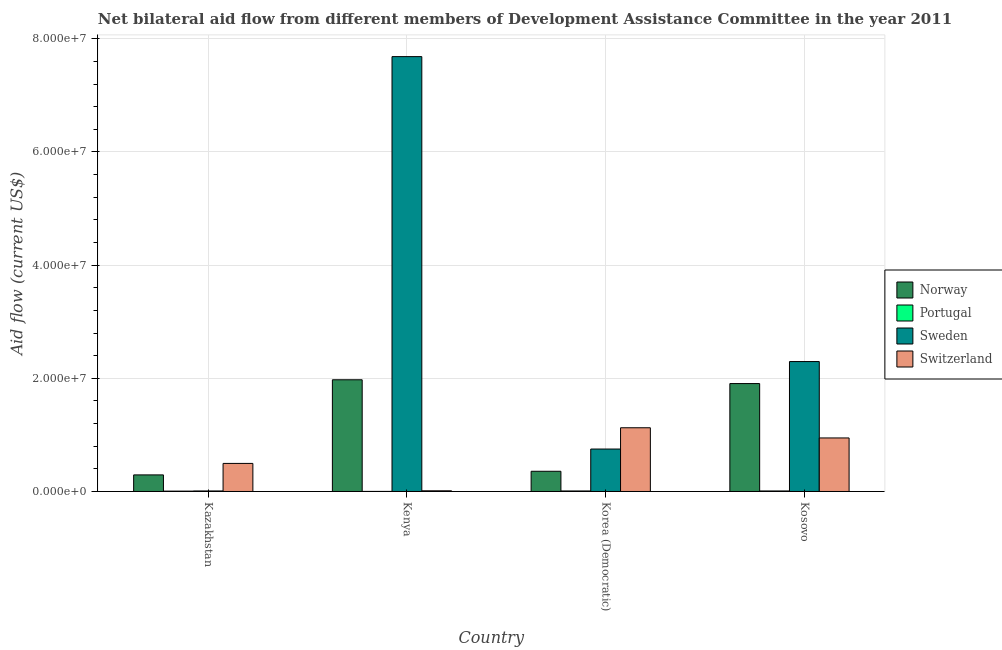How many groups of bars are there?
Ensure brevity in your answer.  4. How many bars are there on the 3rd tick from the left?
Give a very brief answer. 4. How many bars are there on the 4th tick from the right?
Keep it short and to the point. 4. What is the label of the 1st group of bars from the left?
Provide a short and direct response. Kazakhstan. What is the amount of aid given by portugal in Korea (Democratic)?
Your answer should be compact. 9.00e+04. Across all countries, what is the maximum amount of aid given by portugal?
Offer a terse response. 9.00e+04. Across all countries, what is the minimum amount of aid given by norway?
Make the answer very short. 2.93e+06. In which country was the amount of aid given by sweden maximum?
Make the answer very short. Kenya. In which country was the amount of aid given by norway minimum?
Keep it short and to the point. Kazakhstan. What is the total amount of aid given by switzerland in the graph?
Provide a succinct answer. 2.58e+07. What is the difference between the amount of aid given by portugal in Kenya and that in Korea (Democratic)?
Keep it short and to the point. -8.00e+04. What is the difference between the amount of aid given by portugal in Kosovo and the amount of aid given by norway in Kazakhstan?
Your answer should be very brief. -2.84e+06. What is the average amount of aid given by norway per country?
Keep it short and to the point. 1.13e+07. What is the difference between the amount of aid given by portugal and amount of aid given by sweden in Kosovo?
Make the answer very short. -2.29e+07. In how many countries, is the amount of aid given by switzerland greater than 12000000 US$?
Your answer should be compact. 0. What is the ratio of the amount of aid given by switzerland in Kenya to that in Korea (Democratic)?
Make the answer very short. 0.01. Is the amount of aid given by switzerland in Kenya less than that in Korea (Democratic)?
Provide a succinct answer. Yes. Is the difference between the amount of aid given by norway in Kazakhstan and Kosovo greater than the difference between the amount of aid given by sweden in Kazakhstan and Kosovo?
Offer a very short reply. Yes. What is the difference between the highest and the second highest amount of aid given by sweden?
Offer a very short reply. 5.39e+07. What is the difference between the highest and the lowest amount of aid given by norway?
Your answer should be very brief. 1.68e+07. Is it the case that in every country, the sum of the amount of aid given by sweden and amount of aid given by norway is greater than the sum of amount of aid given by switzerland and amount of aid given by portugal?
Keep it short and to the point. No. What does the 2nd bar from the left in Kenya represents?
Keep it short and to the point. Portugal. What does the 2nd bar from the right in Kenya represents?
Ensure brevity in your answer.  Sweden. Are all the bars in the graph horizontal?
Ensure brevity in your answer.  No. What is the difference between two consecutive major ticks on the Y-axis?
Ensure brevity in your answer.  2.00e+07. Are the values on the major ticks of Y-axis written in scientific E-notation?
Offer a terse response. Yes. Does the graph contain grids?
Offer a very short reply. Yes. Where does the legend appear in the graph?
Make the answer very short. Center right. How many legend labels are there?
Your answer should be very brief. 4. What is the title of the graph?
Ensure brevity in your answer.  Net bilateral aid flow from different members of Development Assistance Committee in the year 2011. What is the label or title of the Y-axis?
Your response must be concise. Aid flow (current US$). What is the Aid flow (current US$) in Norway in Kazakhstan?
Offer a very short reply. 2.93e+06. What is the Aid flow (current US$) of Switzerland in Kazakhstan?
Provide a short and direct response. 4.96e+06. What is the Aid flow (current US$) in Norway in Kenya?
Offer a terse response. 1.97e+07. What is the Aid flow (current US$) of Sweden in Kenya?
Make the answer very short. 7.68e+07. What is the Aid flow (current US$) in Switzerland in Kenya?
Ensure brevity in your answer.  1.20e+05. What is the Aid flow (current US$) in Norway in Korea (Democratic)?
Your answer should be very brief. 3.57e+06. What is the Aid flow (current US$) in Portugal in Korea (Democratic)?
Your response must be concise. 9.00e+04. What is the Aid flow (current US$) in Sweden in Korea (Democratic)?
Your answer should be compact. 7.50e+06. What is the Aid flow (current US$) in Switzerland in Korea (Democratic)?
Provide a succinct answer. 1.13e+07. What is the Aid flow (current US$) of Norway in Kosovo?
Provide a short and direct response. 1.91e+07. What is the Aid flow (current US$) of Portugal in Kosovo?
Provide a short and direct response. 9.00e+04. What is the Aid flow (current US$) of Sweden in Kosovo?
Offer a terse response. 2.30e+07. What is the Aid flow (current US$) of Switzerland in Kosovo?
Give a very brief answer. 9.46e+06. Across all countries, what is the maximum Aid flow (current US$) in Norway?
Your answer should be very brief. 1.97e+07. Across all countries, what is the maximum Aid flow (current US$) in Portugal?
Give a very brief answer. 9.00e+04. Across all countries, what is the maximum Aid flow (current US$) in Sweden?
Provide a short and direct response. 7.68e+07. Across all countries, what is the maximum Aid flow (current US$) in Switzerland?
Make the answer very short. 1.13e+07. Across all countries, what is the minimum Aid flow (current US$) in Norway?
Your answer should be compact. 2.93e+06. Across all countries, what is the minimum Aid flow (current US$) of Portugal?
Provide a succinct answer. 10000. Across all countries, what is the minimum Aid flow (current US$) in Sweden?
Give a very brief answer. 9.00e+04. What is the total Aid flow (current US$) in Norway in the graph?
Ensure brevity in your answer.  4.53e+07. What is the total Aid flow (current US$) in Sweden in the graph?
Provide a short and direct response. 1.07e+08. What is the total Aid flow (current US$) of Switzerland in the graph?
Keep it short and to the point. 2.58e+07. What is the difference between the Aid flow (current US$) in Norway in Kazakhstan and that in Kenya?
Make the answer very short. -1.68e+07. What is the difference between the Aid flow (current US$) in Portugal in Kazakhstan and that in Kenya?
Your answer should be very brief. 5.00e+04. What is the difference between the Aid flow (current US$) of Sweden in Kazakhstan and that in Kenya?
Your answer should be very brief. -7.68e+07. What is the difference between the Aid flow (current US$) in Switzerland in Kazakhstan and that in Kenya?
Keep it short and to the point. 4.84e+06. What is the difference between the Aid flow (current US$) of Norway in Kazakhstan and that in Korea (Democratic)?
Keep it short and to the point. -6.40e+05. What is the difference between the Aid flow (current US$) in Portugal in Kazakhstan and that in Korea (Democratic)?
Give a very brief answer. -3.00e+04. What is the difference between the Aid flow (current US$) in Sweden in Kazakhstan and that in Korea (Democratic)?
Provide a short and direct response. -7.41e+06. What is the difference between the Aid flow (current US$) of Switzerland in Kazakhstan and that in Korea (Democratic)?
Your answer should be compact. -6.30e+06. What is the difference between the Aid flow (current US$) of Norway in Kazakhstan and that in Kosovo?
Your response must be concise. -1.61e+07. What is the difference between the Aid flow (current US$) in Portugal in Kazakhstan and that in Kosovo?
Offer a very short reply. -3.00e+04. What is the difference between the Aid flow (current US$) in Sweden in Kazakhstan and that in Kosovo?
Give a very brief answer. -2.29e+07. What is the difference between the Aid flow (current US$) of Switzerland in Kazakhstan and that in Kosovo?
Keep it short and to the point. -4.50e+06. What is the difference between the Aid flow (current US$) in Norway in Kenya and that in Korea (Democratic)?
Provide a succinct answer. 1.62e+07. What is the difference between the Aid flow (current US$) of Sweden in Kenya and that in Korea (Democratic)?
Your response must be concise. 6.94e+07. What is the difference between the Aid flow (current US$) of Switzerland in Kenya and that in Korea (Democratic)?
Your answer should be very brief. -1.11e+07. What is the difference between the Aid flow (current US$) of Norway in Kenya and that in Kosovo?
Your response must be concise. 6.70e+05. What is the difference between the Aid flow (current US$) of Portugal in Kenya and that in Kosovo?
Offer a very short reply. -8.00e+04. What is the difference between the Aid flow (current US$) in Sweden in Kenya and that in Kosovo?
Offer a very short reply. 5.39e+07. What is the difference between the Aid flow (current US$) in Switzerland in Kenya and that in Kosovo?
Make the answer very short. -9.34e+06. What is the difference between the Aid flow (current US$) of Norway in Korea (Democratic) and that in Kosovo?
Make the answer very short. -1.55e+07. What is the difference between the Aid flow (current US$) in Portugal in Korea (Democratic) and that in Kosovo?
Your answer should be compact. 0. What is the difference between the Aid flow (current US$) in Sweden in Korea (Democratic) and that in Kosovo?
Provide a succinct answer. -1.55e+07. What is the difference between the Aid flow (current US$) of Switzerland in Korea (Democratic) and that in Kosovo?
Keep it short and to the point. 1.80e+06. What is the difference between the Aid flow (current US$) in Norway in Kazakhstan and the Aid flow (current US$) in Portugal in Kenya?
Ensure brevity in your answer.  2.92e+06. What is the difference between the Aid flow (current US$) of Norway in Kazakhstan and the Aid flow (current US$) of Sweden in Kenya?
Provide a short and direct response. -7.39e+07. What is the difference between the Aid flow (current US$) in Norway in Kazakhstan and the Aid flow (current US$) in Switzerland in Kenya?
Ensure brevity in your answer.  2.81e+06. What is the difference between the Aid flow (current US$) of Portugal in Kazakhstan and the Aid flow (current US$) of Sweden in Kenya?
Your answer should be compact. -7.68e+07. What is the difference between the Aid flow (current US$) of Portugal in Kazakhstan and the Aid flow (current US$) of Switzerland in Kenya?
Your response must be concise. -6.00e+04. What is the difference between the Aid flow (current US$) of Norway in Kazakhstan and the Aid flow (current US$) of Portugal in Korea (Democratic)?
Make the answer very short. 2.84e+06. What is the difference between the Aid flow (current US$) of Norway in Kazakhstan and the Aid flow (current US$) of Sweden in Korea (Democratic)?
Your answer should be compact. -4.57e+06. What is the difference between the Aid flow (current US$) of Norway in Kazakhstan and the Aid flow (current US$) of Switzerland in Korea (Democratic)?
Ensure brevity in your answer.  -8.33e+06. What is the difference between the Aid flow (current US$) in Portugal in Kazakhstan and the Aid flow (current US$) in Sweden in Korea (Democratic)?
Offer a very short reply. -7.44e+06. What is the difference between the Aid flow (current US$) in Portugal in Kazakhstan and the Aid flow (current US$) in Switzerland in Korea (Democratic)?
Keep it short and to the point. -1.12e+07. What is the difference between the Aid flow (current US$) of Sweden in Kazakhstan and the Aid flow (current US$) of Switzerland in Korea (Democratic)?
Offer a terse response. -1.12e+07. What is the difference between the Aid flow (current US$) in Norway in Kazakhstan and the Aid flow (current US$) in Portugal in Kosovo?
Give a very brief answer. 2.84e+06. What is the difference between the Aid flow (current US$) in Norway in Kazakhstan and the Aid flow (current US$) in Sweden in Kosovo?
Offer a terse response. -2.00e+07. What is the difference between the Aid flow (current US$) of Norway in Kazakhstan and the Aid flow (current US$) of Switzerland in Kosovo?
Keep it short and to the point. -6.53e+06. What is the difference between the Aid flow (current US$) in Portugal in Kazakhstan and the Aid flow (current US$) in Sweden in Kosovo?
Ensure brevity in your answer.  -2.29e+07. What is the difference between the Aid flow (current US$) of Portugal in Kazakhstan and the Aid flow (current US$) of Switzerland in Kosovo?
Keep it short and to the point. -9.40e+06. What is the difference between the Aid flow (current US$) in Sweden in Kazakhstan and the Aid flow (current US$) in Switzerland in Kosovo?
Ensure brevity in your answer.  -9.37e+06. What is the difference between the Aid flow (current US$) in Norway in Kenya and the Aid flow (current US$) in Portugal in Korea (Democratic)?
Offer a terse response. 1.96e+07. What is the difference between the Aid flow (current US$) in Norway in Kenya and the Aid flow (current US$) in Sweden in Korea (Democratic)?
Keep it short and to the point. 1.22e+07. What is the difference between the Aid flow (current US$) in Norway in Kenya and the Aid flow (current US$) in Switzerland in Korea (Democratic)?
Provide a succinct answer. 8.48e+06. What is the difference between the Aid flow (current US$) in Portugal in Kenya and the Aid flow (current US$) in Sweden in Korea (Democratic)?
Keep it short and to the point. -7.49e+06. What is the difference between the Aid flow (current US$) in Portugal in Kenya and the Aid flow (current US$) in Switzerland in Korea (Democratic)?
Offer a terse response. -1.12e+07. What is the difference between the Aid flow (current US$) of Sweden in Kenya and the Aid flow (current US$) of Switzerland in Korea (Democratic)?
Offer a terse response. 6.56e+07. What is the difference between the Aid flow (current US$) of Norway in Kenya and the Aid flow (current US$) of Portugal in Kosovo?
Provide a short and direct response. 1.96e+07. What is the difference between the Aid flow (current US$) in Norway in Kenya and the Aid flow (current US$) in Sweden in Kosovo?
Offer a terse response. -3.22e+06. What is the difference between the Aid flow (current US$) of Norway in Kenya and the Aid flow (current US$) of Switzerland in Kosovo?
Provide a succinct answer. 1.03e+07. What is the difference between the Aid flow (current US$) in Portugal in Kenya and the Aid flow (current US$) in Sweden in Kosovo?
Make the answer very short. -2.30e+07. What is the difference between the Aid flow (current US$) of Portugal in Kenya and the Aid flow (current US$) of Switzerland in Kosovo?
Offer a very short reply. -9.45e+06. What is the difference between the Aid flow (current US$) in Sweden in Kenya and the Aid flow (current US$) in Switzerland in Kosovo?
Your answer should be compact. 6.74e+07. What is the difference between the Aid flow (current US$) in Norway in Korea (Democratic) and the Aid flow (current US$) in Portugal in Kosovo?
Your response must be concise. 3.48e+06. What is the difference between the Aid flow (current US$) in Norway in Korea (Democratic) and the Aid flow (current US$) in Sweden in Kosovo?
Provide a succinct answer. -1.94e+07. What is the difference between the Aid flow (current US$) in Norway in Korea (Democratic) and the Aid flow (current US$) in Switzerland in Kosovo?
Ensure brevity in your answer.  -5.89e+06. What is the difference between the Aid flow (current US$) of Portugal in Korea (Democratic) and the Aid flow (current US$) of Sweden in Kosovo?
Your answer should be very brief. -2.29e+07. What is the difference between the Aid flow (current US$) of Portugal in Korea (Democratic) and the Aid flow (current US$) of Switzerland in Kosovo?
Offer a terse response. -9.37e+06. What is the difference between the Aid flow (current US$) in Sweden in Korea (Democratic) and the Aid flow (current US$) in Switzerland in Kosovo?
Keep it short and to the point. -1.96e+06. What is the average Aid flow (current US$) of Norway per country?
Ensure brevity in your answer.  1.13e+07. What is the average Aid flow (current US$) of Portugal per country?
Provide a succinct answer. 6.25e+04. What is the average Aid flow (current US$) in Sweden per country?
Make the answer very short. 2.68e+07. What is the average Aid flow (current US$) of Switzerland per country?
Provide a succinct answer. 6.45e+06. What is the difference between the Aid flow (current US$) in Norway and Aid flow (current US$) in Portugal in Kazakhstan?
Offer a terse response. 2.87e+06. What is the difference between the Aid flow (current US$) in Norway and Aid flow (current US$) in Sweden in Kazakhstan?
Make the answer very short. 2.84e+06. What is the difference between the Aid flow (current US$) of Norway and Aid flow (current US$) of Switzerland in Kazakhstan?
Your response must be concise. -2.03e+06. What is the difference between the Aid flow (current US$) of Portugal and Aid flow (current US$) of Switzerland in Kazakhstan?
Provide a short and direct response. -4.90e+06. What is the difference between the Aid flow (current US$) in Sweden and Aid flow (current US$) in Switzerland in Kazakhstan?
Make the answer very short. -4.87e+06. What is the difference between the Aid flow (current US$) in Norway and Aid flow (current US$) in Portugal in Kenya?
Make the answer very short. 1.97e+07. What is the difference between the Aid flow (current US$) of Norway and Aid flow (current US$) of Sweden in Kenya?
Keep it short and to the point. -5.71e+07. What is the difference between the Aid flow (current US$) of Norway and Aid flow (current US$) of Switzerland in Kenya?
Give a very brief answer. 1.96e+07. What is the difference between the Aid flow (current US$) in Portugal and Aid flow (current US$) in Sweden in Kenya?
Provide a short and direct response. -7.68e+07. What is the difference between the Aid flow (current US$) of Portugal and Aid flow (current US$) of Switzerland in Kenya?
Keep it short and to the point. -1.10e+05. What is the difference between the Aid flow (current US$) of Sweden and Aid flow (current US$) of Switzerland in Kenya?
Keep it short and to the point. 7.67e+07. What is the difference between the Aid flow (current US$) in Norway and Aid flow (current US$) in Portugal in Korea (Democratic)?
Provide a succinct answer. 3.48e+06. What is the difference between the Aid flow (current US$) of Norway and Aid flow (current US$) of Sweden in Korea (Democratic)?
Provide a short and direct response. -3.93e+06. What is the difference between the Aid flow (current US$) of Norway and Aid flow (current US$) of Switzerland in Korea (Democratic)?
Provide a succinct answer. -7.69e+06. What is the difference between the Aid flow (current US$) in Portugal and Aid flow (current US$) in Sweden in Korea (Democratic)?
Provide a succinct answer. -7.41e+06. What is the difference between the Aid flow (current US$) of Portugal and Aid flow (current US$) of Switzerland in Korea (Democratic)?
Offer a terse response. -1.12e+07. What is the difference between the Aid flow (current US$) in Sweden and Aid flow (current US$) in Switzerland in Korea (Democratic)?
Your response must be concise. -3.76e+06. What is the difference between the Aid flow (current US$) in Norway and Aid flow (current US$) in Portugal in Kosovo?
Make the answer very short. 1.90e+07. What is the difference between the Aid flow (current US$) in Norway and Aid flow (current US$) in Sweden in Kosovo?
Offer a very short reply. -3.89e+06. What is the difference between the Aid flow (current US$) of Norway and Aid flow (current US$) of Switzerland in Kosovo?
Keep it short and to the point. 9.61e+06. What is the difference between the Aid flow (current US$) in Portugal and Aid flow (current US$) in Sweden in Kosovo?
Ensure brevity in your answer.  -2.29e+07. What is the difference between the Aid flow (current US$) of Portugal and Aid flow (current US$) of Switzerland in Kosovo?
Give a very brief answer. -9.37e+06. What is the difference between the Aid flow (current US$) of Sweden and Aid flow (current US$) of Switzerland in Kosovo?
Make the answer very short. 1.35e+07. What is the ratio of the Aid flow (current US$) of Norway in Kazakhstan to that in Kenya?
Provide a short and direct response. 0.15. What is the ratio of the Aid flow (current US$) in Sweden in Kazakhstan to that in Kenya?
Your answer should be compact. 0. What is the ratio of the Aid flow (current US$) of Switzerland in Kazakhstan to that in Kenya?
Give a very brief answer. 41.33. What is the ratio of the Aid flow (current US$) of Norway in Kazakhstan to that in Korea (Democratic)?
Give a very brief answer. 0.82. What is the ratio of the Aid flow (current US$) in Sweden in Kazakhstan to that in Korea (Democratic)?
Offer a very short reply. 0.01. What is the ratio of the Aid flow (current US$) of Switzerland in Kazakhstan to that in Korea (Democratic)?
Your answer should be very brief. 0.44. What is the ratio of the Aid flow (current US$) of Norway in Kazakhstan to that in Kosovo?
Offer a very short reply. 0.15. What is the ratio of the Aid flow (current US$) of Sweden in Kazakhstan to that in Kosovo?
Ensure brevity in your answer.  0. What is the ratio of the Aid flow (current US$) of Switzerland in Kazakhstan to that in Kosovo?
Offer a very short reply. 0.52. What is the ratio of the Aid flow (current US$) of Norway in Kenya to that in Korea (Democratic)?
Your answer should be compact. 5.53. What is the ratio of the Aid flow (current US$) in Portugal in Kenya to that in Korea (Democratic)?
Provide a short and direct response. 0.11. What is the ratio of the Aid flow (current US$) of Sweden in Kenya to that in Korea (Democratic)?
Give a very brief answer. 10.25. What is the ratio of the Aid flow (current US$) in Switzerland in Kenya to that in Korea (Democratic)?
Your response must be concise. 0.01. What is the ratio of the Aid flow (current US$) in Norway in Kenya to that in Kosovo?
Your answer should be very brief. 1.04. What is the ratio of the Aid flow (current US$) of Portugal in Kenya to that in Kosovo?
Ensure brevity in your answer.  0.11. What is the ratio of the Aid flow (current US$) in Sweden in Kenya to that in Kosovo?
Make the answer very short. 3.35. What is the ratio of the Aid flow (current US$) of Switzerland in Kenya to that in Kosovo?
Offer a very short reply. 0.01. What is the ratio of the Aid flow (current US$) of Norway in Korea (Democratic) to that in Kosovo?
Your response must be concise. 0.19. What is the ratio of the Aid flow (current US$) in Sweden in Korea (Democratic) to that in Kosovo?
Provide a short and direct response. 0.33. What is the ratio of the Aid flow (current US$) of Switzerland in Korea (Democratic) to that in Kosovo?
Provide a succinct answer. 1.19. What is the difference between the highest and the second highest Aid flow (current US$) in Norway?
Ensure brevity in your answer.  6.70e+05. What is the difference between the highest and the second highest Aid flow (current US$) of Portugal?
Provide a short and direct response. 0. What is the difference between the highest and the second highest Aid flow (current US$) of Sweden?
Offer a terse response. 5.39e+07. What is the difference between the highest and the second highest Aid flow (current US$) of Switzerland?
Your answer should be very brief. 1.80e+06. What is the difference between the highest and the lowest Aid flow (current US$) in Norway?
Make the answer very short. 1.68e+07. What is the difference between the highest and the lowest Aid flow (current US$) of Sweden?
Keep it short and to the point. 7.68e+07. What is the difference between the highest and the lowest Aid flow (current US$) of Switzerland?
Ensure brevity in your answer.  1.11e+07. 